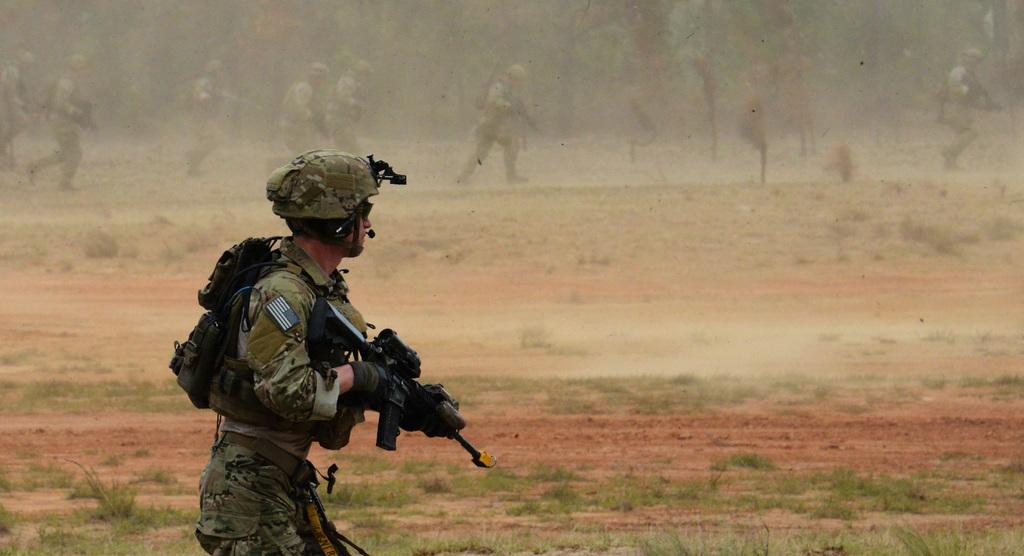What is the main subject of the image? There is a person in the image. What is the person wearing? The person is wearing a backpack. What is the person holding? The person is holding a gun. Are there any other people in the image? Yes, there are other people in the image. What are the other people holding? The other people are also holding guns. What type of yam is being served for breakfast in the image? There is no yam or breakfast depicted in the image; it features a person and other people holding guns. 